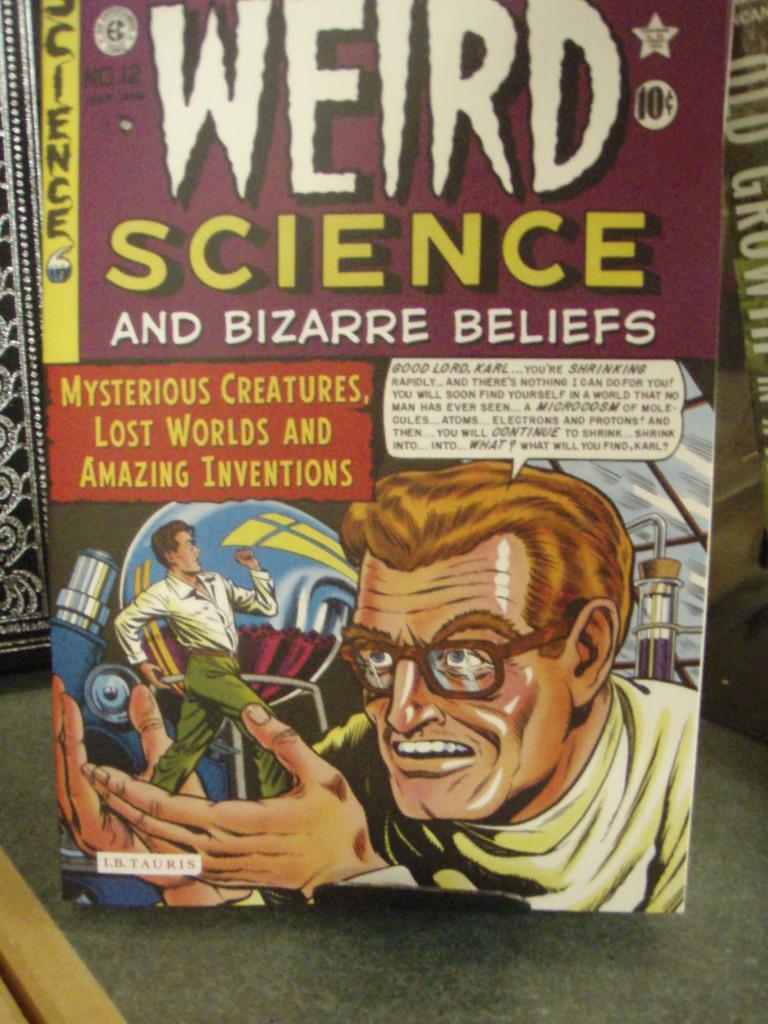What kind of beliefs can be found in this comic?
Provide a short and direct response. Bizarre. What is the title of the book?
Make the answer very short. Weird science and bizarre beliefs. 